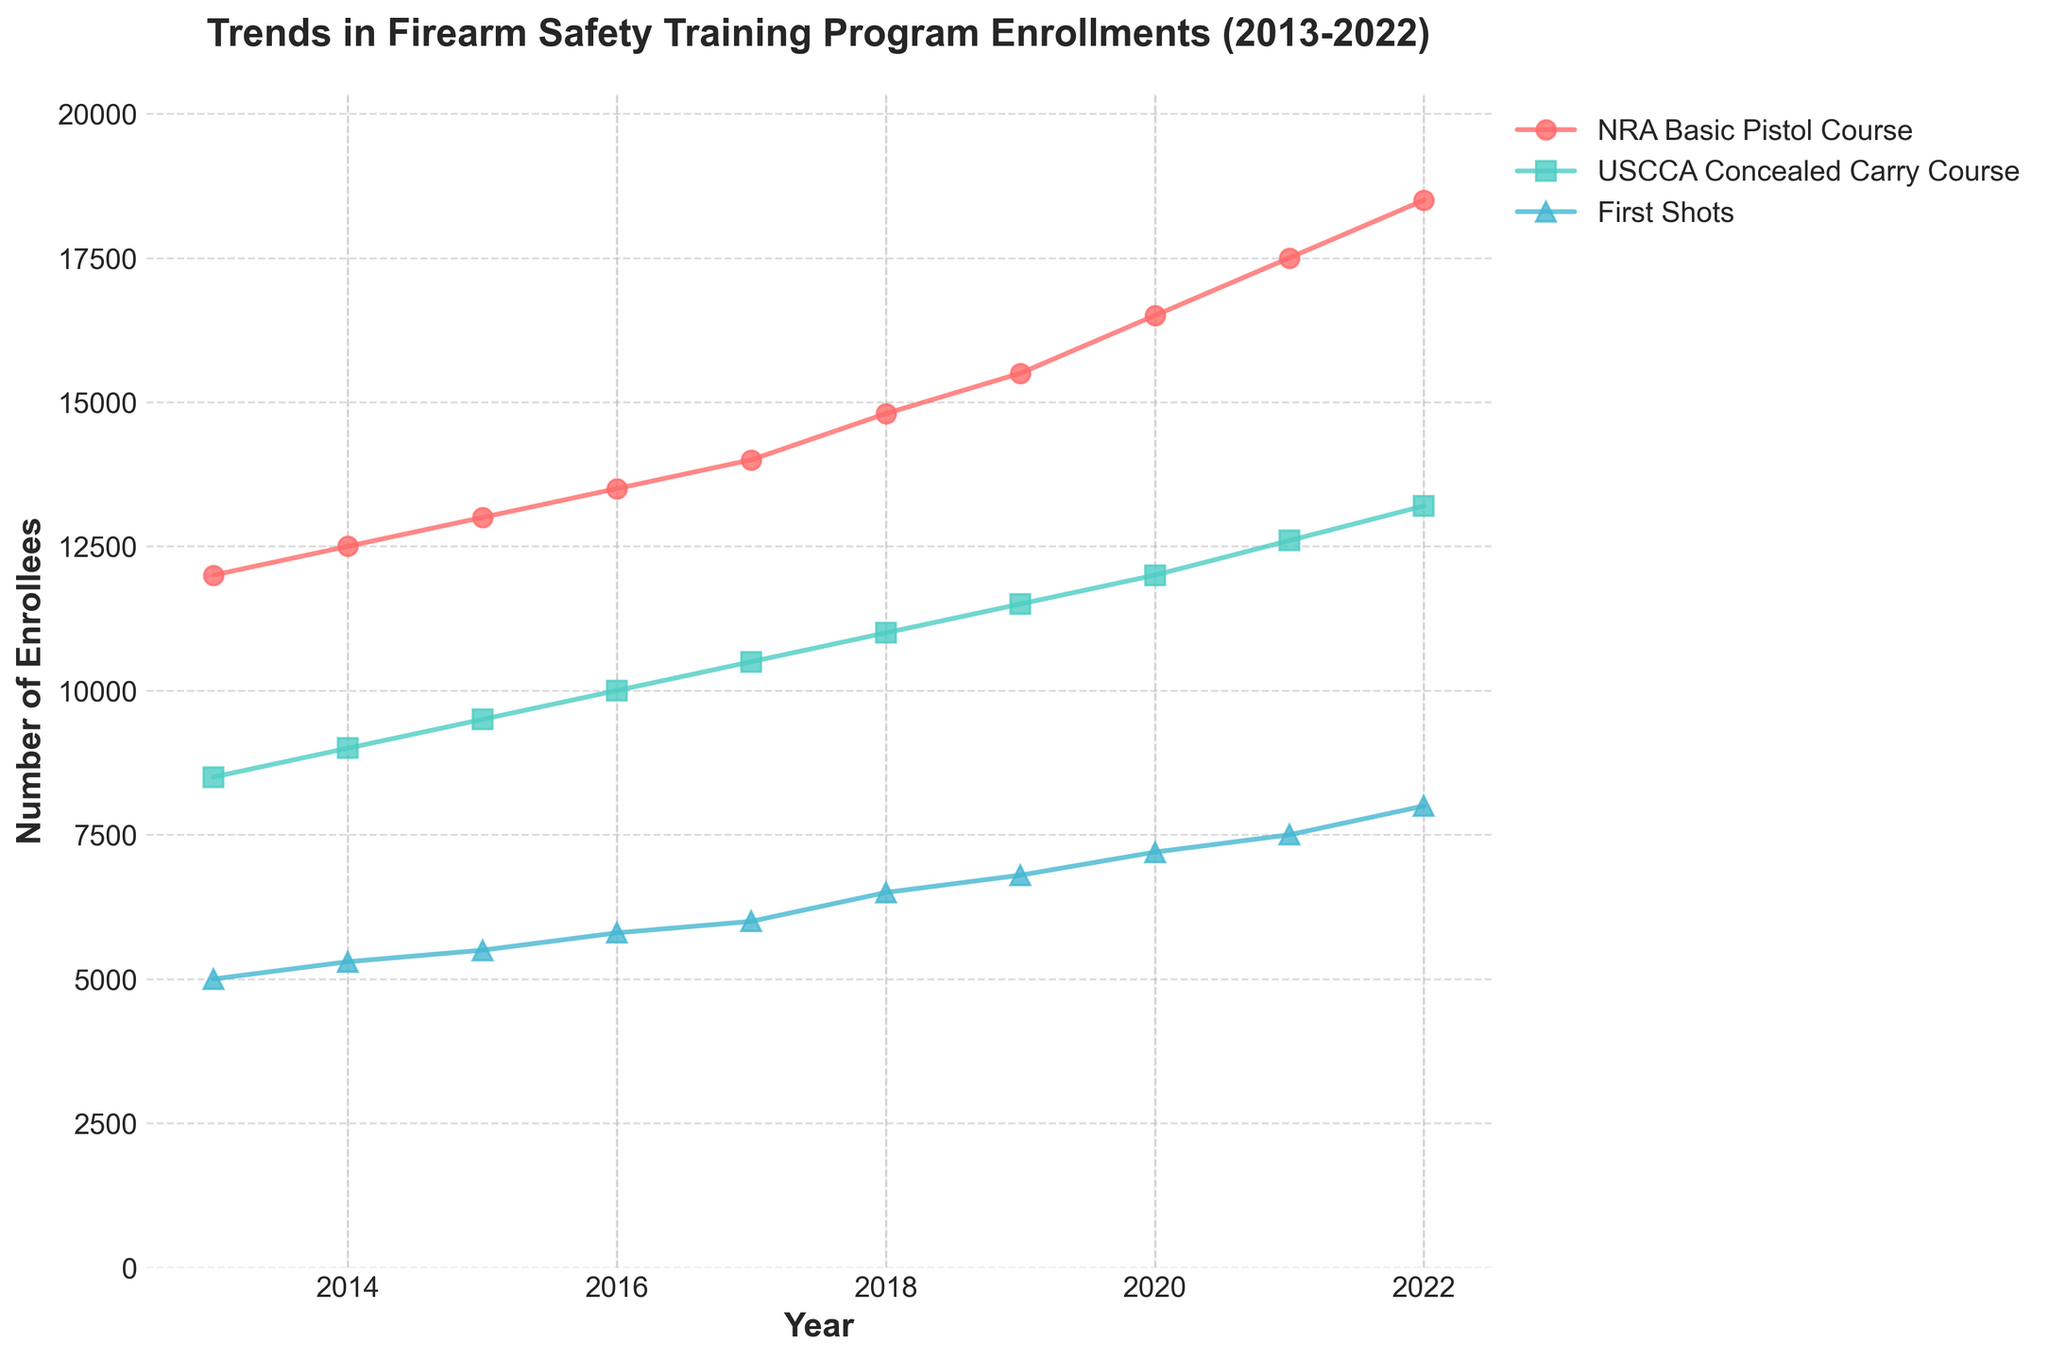What is the title of the plot? The title is found at the top of the plot and it indicates the main subject of the visualization.
Answer: Trends in Firearm Safety Training Program Enrollments (2013-2022) How many different programs are displayed in the plot? By examining the legend, we can see three distinct programs listed, each represented by a different line and color.
Answer: 3 Which program had the highest number of enrollees in 2022? By following the lines to the endpoint at 2022 and checking the corresponding values, the NRA Basic Pistol Course has the highest number of enrollees.
Answer: NRA Basic Pistol Course How does the trend of enrollees in the "First Shots" program compare from 2013 to 2022? Observing the "First Shots" line over the years, it shows a consistent increase in the number of enrollees from 2013 to 2022.
Answer: It consistently increased Which program showed the most significant growth in enrollees between 2013 and 2022? We can determine this by comparing the change in enrollees from 2013 to 2022 for each program. The NRA Basic Pistol Course shows the largest increase from 12,000 to 18,500 enrollees.
Answer: NRA Basic Pistol Course What is the approximate difference in enrollees between the NRA Basic Pistol Course and the USCCA Concealed Carry Course in 2020? Locate the enrollees for both programs in 2020 and subtract the smaller number from the larger one. In 2020, the NRA Basic Pistol Course had 16,500 enrollees, and the USCCA Concealed Carry Course had 12,000. The difference is 16,500 - 12,000.
Answer: 4,500 What is the average number of enrollees in the USCCA Concealed Carry Course over the 10-year period? To find the average, sum the number of enrollees each year and divide by the number of years (10). The sum of enrollees from 2013 to 2022 is 106,800. Thus, the average is 106,800 / 10.
Answer: 10,680 In which year did the "First Shots" program see the most significant increase in enrollees from the previous year? By looking at the "First Shots" line, compare the annual increases. The largest jump is from 2021 to 2022, where enrollees increased from 7,500 to 8,000.
Answer: 2022 How did the number of enrollees in the USCCA Concealed Carry Course change from 2017 to 2018? Compare the number of enrollees in 2017 (10,500) and in 2018 (11,000). The increase can be found by subtracting the 2017 value from the 2018 value.
Answer: Increased by 500 